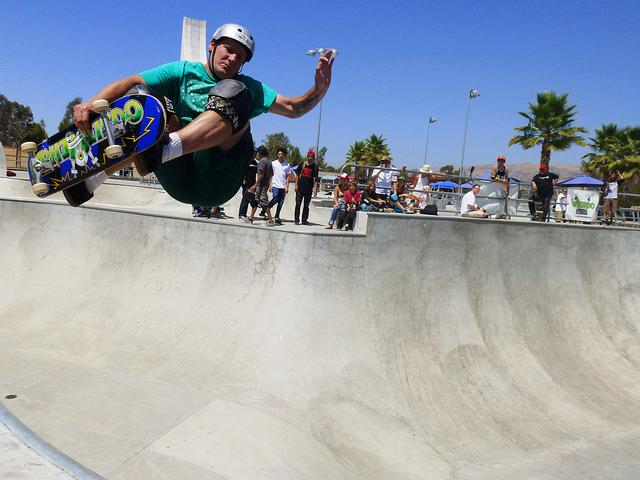What is this skateboarding feature? ollie 